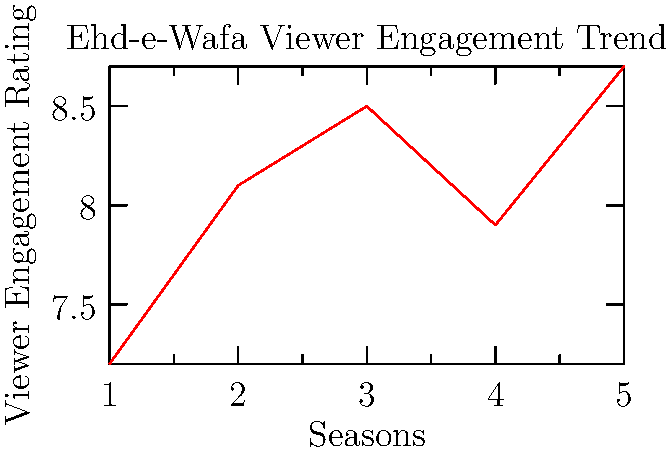Based on the line graph showing viewer engagement ratings for the ARY Digital drama series "Ehd-e-Wafa" over five seasons, which season marked the most significant improvement in viewer engagement compared to its preceding season? To determine the season with the most significant improvement in viewer engagement, we need to calculate the difference in ratings between each consecutive season:

1. Between Season 1 and 2: $8.1 - 7.2 = 0.9$
2. Between Season 2 and 3: $8.5 - 8.1 = 0.4$
3. Between Season 3 and 4: $7.9 - 8.5 = -0.6$ (a decrease)
4. Between Season 4 and 5: $8.7 - 7.9 = 0.8$

The largest positive difference is 0.9, which occurred between Season 1 and Season 2. This indicates that the most significant improvement in viewer engagement happened from Season 1 to Season 2.
Answer: Season 2 